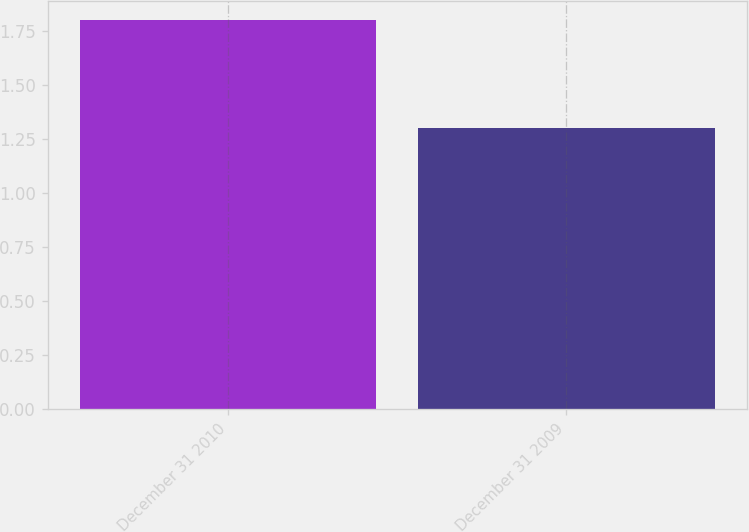<chart> <loc_0><loc_0><loc_500><loc_500><bar_chart><fcel>December 31 2010<fcel>December 31 2009<nl><fcel>1.8<fcel>1.3<nl></chart> 